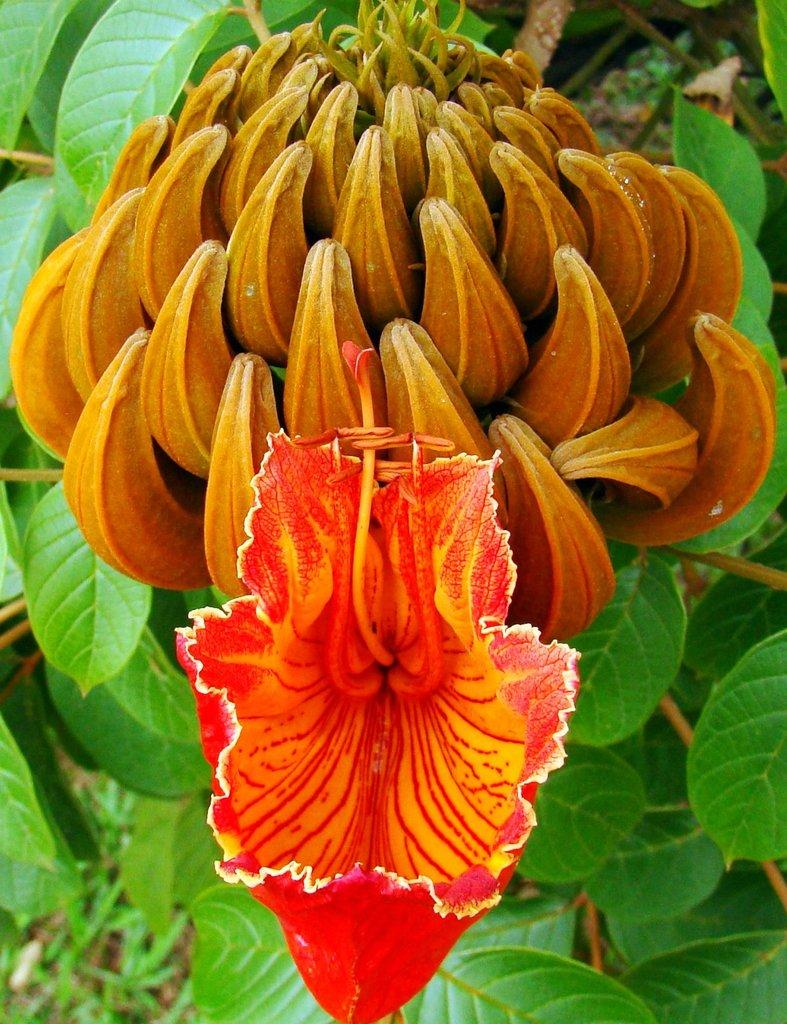What is present in the image? There is a plant in the image. What can be observed about the plant? The plant has a flower and buds. What type of music can be heard coming from the plant in the image? There is no music coming from the plant in the image, as plants do not produce or emit music. 